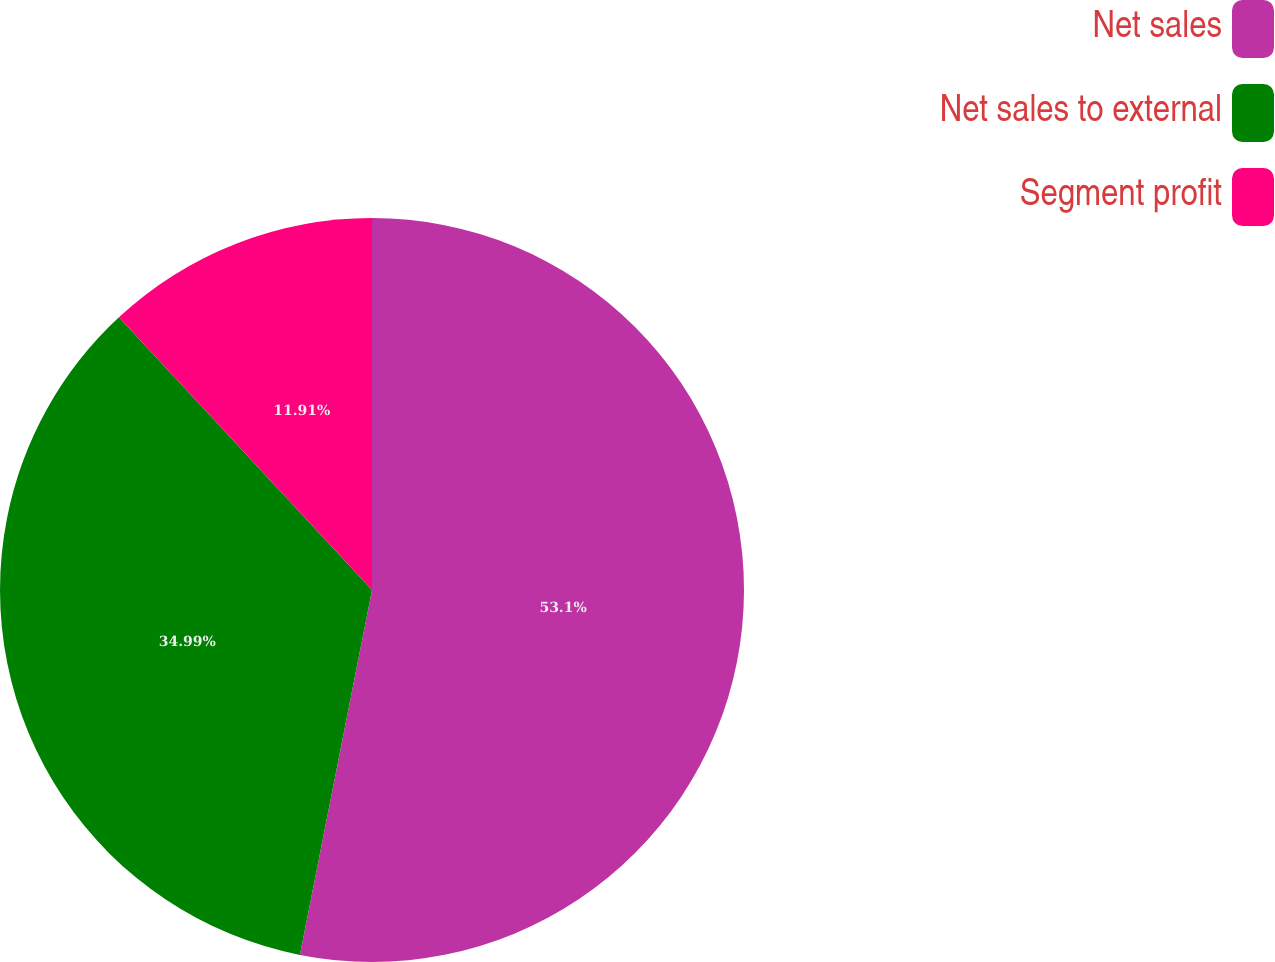Convert chart. <chart><loc_0><loc_0><loc_500><loc_500><pie_chart><fcel>Net sales<fcel>Net sales to external<fcel>Segment profit<nl><fcel>53.11%<fcel>34.99%<fcel>11.91%<nl></chart> 